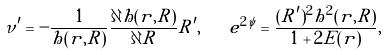<formula> <loc_0><loc_0><loc_500><loc_500>\nu ^ { \prime } = - \frac { 1 } { h ( r , R ) } \frac { \partial h ( r , R ) } { \partial R } R ^ { \prime } , \quad e ^ { 2 \psi } = \frac { ( R ^ { \prime } ) ^ { 2 } h ^ { 2 } ( r , R ) } { 1 + 2 E ( r ) } ,</formula> 